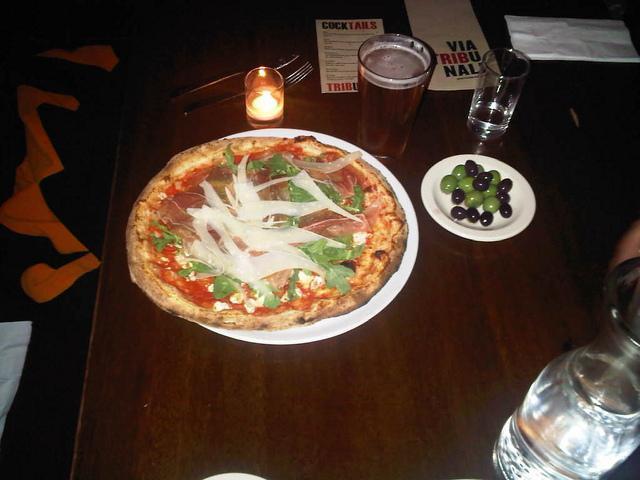How many plates are on the table?
Give a very brief answer. 2. How many cups can you see?
Give a very brief answer. 2. 